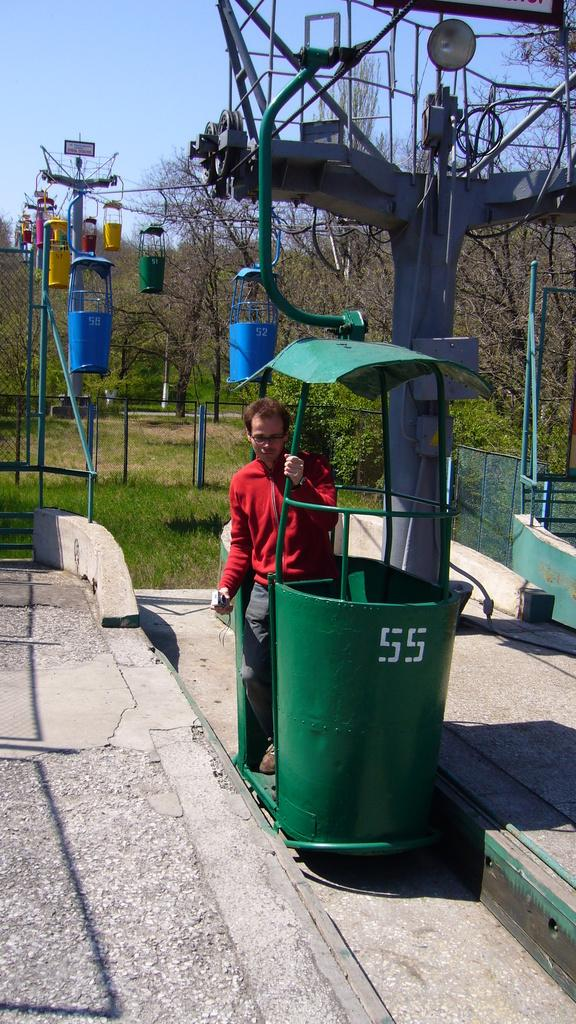<image>
Relay a brief, clear account of the picture shown. a man in front of a green bin with the numbers 55 on 